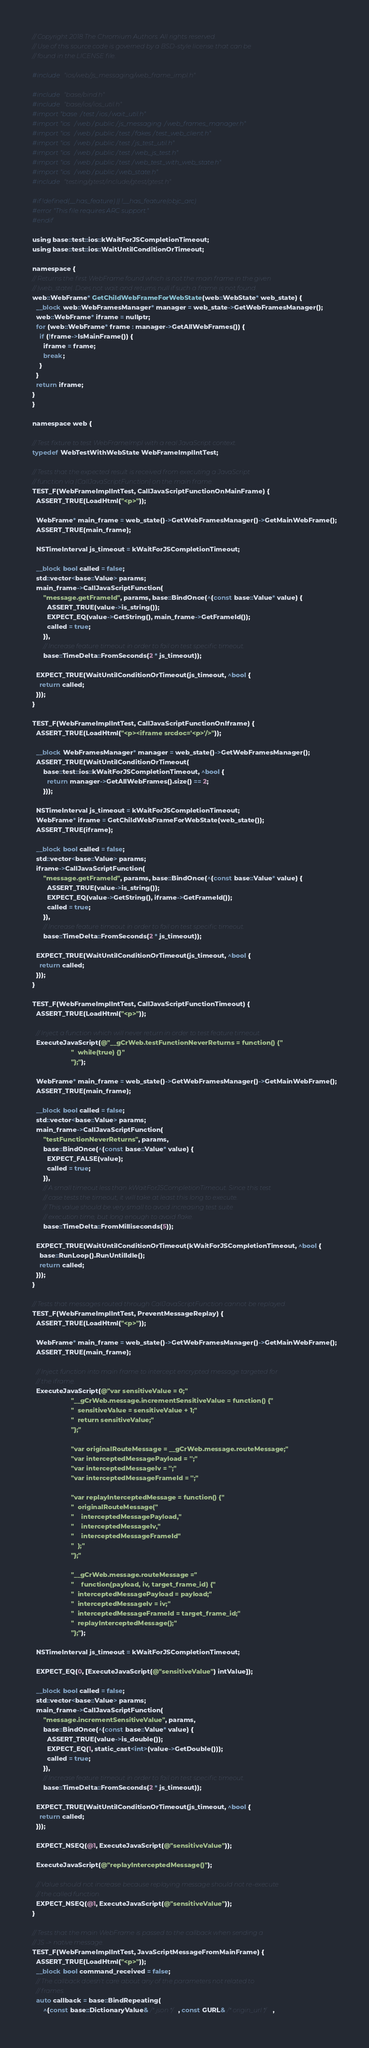<code> <loc_0><loc_0><loc_500><loc_500><_ObjectiveC_>// Copyright 2018 The Chromium Authors. All rights reserved.
// Use of this source code is governed by a BSD-style license that can be
// found in the LICENSE file.

#include "ios/web/js_messaging/web_frame_impl.h"

#include "base/bind.h"
#include "base/ios/ios_util.h"
#import "base/test/ios/wait_util.h"
#import "ios/web/public/js_messaging/web_frames_manager.h"
#import "ios/web/public/test/fakes/test_web_client.h"
#import "ios/web/public/test/js_test_util.h"
#import "ios/web/public/test/web_js_test.h"
#import "ios/web/public/test/web_test_with_web_state.h"
#import "ios/web/public/web_state.h"
#include "testing/gtest/include/gtest/gtest.h"

#if !defined(__has_feature) || !__has_feature(objc_arc)
#error "This file requires ARC support."
#endif

using base::test::ios::kWaitForJSCompletionTimeout;
using base::test::ios::WaitUntilConditionOrTimeout;

namespace {
// Returns the first WebFrame found which is not the main frame in the given
// |web_state|. Does not wait and returns null if such a frame is not found.
web::WebFrame* GetChildWebFrameForWebState(web::WebState* web_state) {
  __block web::WebFramesManager* manager = web_state->GetWebFramesManager();
  web::WebFrame* iframe = nullptr;
  for (web::WebFrame* frame : manager->GetAllWebFrames()) {
    if (!frame->IsMainFrame()) {
      iframe = frame;
      break;
    }
  }
  return iframe;
}
}

namespace web {

// Test fixture to test WebFrameImpl with a real JavaScript context.
typedef WebTestWithWebState WebFrameImplIntTest;

// Tests that the expected result is received from executing a JavaScript
// function via |CallJavaScriptFunction| on the main frame.
TEST_F(WebFrameImplIntTest, CallJavaScriptFunctionOnMainFrame) {
  ASSERT_TRUE(LoadHtml("<p>"));

  WebFrame* main_frame = web_state()->GetWebFramesManager()->GetMainWebFrame();
  ASSERT_TRUE(main_frame);

  NSTimeInterval js_timeout = kWaitForJSCompletionTimeout;

  __block bool called = false;
  std::vector<base::Value> params;
  main_frame->CallJavaScriptFunction(
      "message.getFrameId", params, base::BindOnce(^(const base::Value* value) {
        ASSERT_TRUE(value->is_string());
        EXPECT_EQ(value->GetString(), main_frame->GetFrameId());
        called = true;
      }),
      // Increase feature timeout in order to fail on test specific timeout.
      base::TimeDelta::FromSeconds(2 * js_timeout));

  EXPECT_TRUE(WaitUntilConditionOrTimeout(js_timeout, ^bool {
    return called;
  }));
}

TEST_F(WebFrameImplIntTest, CallJavaScriptFunctionOnIframe) {
  ASSERT_TRUE(LoadHtml("<p><iframe srcdoc='<p>'/>"));

  __block WebFramesManager* manager = web_state()->GetWebFramesManager();
  ASSERT_TRUE(WaitUntilConditionOrTimeout(
      base::test::ios::kWaitForJSCompletionTimeout, ^bool {
        return manager->GetAllWebFrames().size() == 2;
      }));

  NSTimeInterval js_timeout = kWaitForJSCompletionTimeout;
  WebFrame* iframe = GetChildWebFrameForWebState(web_state());
  ASSERT_TRUE(iframe);

  __block bool called = false;
  std::vector<base::Value> params;
  iframe->CallJavaScriptFunction(
      "message.getFrameId", params, base::BindOnce(^(const base::Value* value) {
        ASSERT_TRUE(value->is_string());
        EXPECT_EQ(value->GetString(), iframe->GetFrameId());
        called = true;
      }),
      // Increase feature timeout in order to fail on test specific timeout.
      base::TimeDelta::FromSeconds(2 * js_timeout));

  EXPECT_TRUE(WaitUntilConditionOrTimeout(js_timeout, ^bool {
    return called;
  }));
}

TEST_F(WebFrameImplIntTest, CallJavaScriptFunctionTimeout) {
  ASSERT_TRUE(LoadHtml("<p>"));

  // Inject a function which will never return in order to test feature timeout.
  ExecuteJavaScript(@"__gCrWeb.testFunctionNeverReturns = function() {"
                     "  while(true) {}"
                     "};");

  WebFrame* main_frame = web_state()->GetWebFramesManager()->GetMainWebFrame();
  ASSERT_TRUE(main_frame);

  __block bool called = false;
  std::vector<base::Value> params;
  main_frame->CallJavaScriptFunction(
      "testFunctionNeverReturns", params,
      base::BindOnce(^(const base::Value* value) {
        EXPECT_FALSE(value);
        called = true;
      }),
      // A small timeout less than kWaitForJSCompletionTimeout. Since this test
      // case tests the timeout, it will take at least this long to execute.
      // This value should be very small to avoid increasing test suite
      // execution time, but long enough to avoid flake.
      base::TimeDelta::FromMilliseconds(5));

  EXPECT_TRUE(WaitUntilConditionOrTimeout(kWaitForJSCompletionTimeout, ^bool {
    base::RunLoop().RunUntilIdle();
    return called;
  }));
}

// Tests that messages routed through CallJavaScriptFunction cannot be replayed.
TEST_F(WebFrameImplIntTest, PreventMessageReplay) {
  ASSERT_TRUE(LoadHtml("<p>"));

  WebFrame* main_frame = web_state()->GetWebFramesManager()->GetMainWebFrame();
  ASSERT_TRUE(main_frame);

  // Inject function into main frame to intercept encrypted message targeted for
  // the iframe.
  ExecuteJavaScript(@"var sensitiveValue = 0;"
                     "__gCrWeb.message.incrementSensitiveValue = function() {"
                     "  sensitiveValue = sensitiveValue + 1;"
                     "  return sensitiveValue;"
                     "};"

                     "var originalRouteMessage = __gCrWeb.message.routeMessage;"
                     "var interceptedMessagePayload = '';"
                     "var interceptedMessageIv = '';"
                     "var interceptedMessageFrameId = '';"

                     "var replayInterceptedMessage = function() {"
                     "  originalRouteMessage("
                     "    interceptedMessagePayload,"
                     "    interceptedMessageIv,"
                     "    interceptedMessageFrameId"
                     "  );"
                     "};"

                     "__gCrWeb.message.routeMessage ="
                     "    function(payload, iv, target_frame_id) {"
                     "  interceptedMessagePayload = payload;"
                     "  interceptedMessageIv = iv;"
                     "  interceptedMessageFrameId = target_frame_id;"
                     "  replayInterceptedMessage();"
                     "};");

  NSTimeInterval js_timeout = kWaitForJSCompletionTimeout;

  EXPECT_EQ(0, [ExecuteJavaScript(@"sensitiveValue") intValue]);

  __block bool called = false;
  std::vector<base::Value> params;
  main_frame->CallJavaScriptFunction(
      "message.incrementSensitiveValue", params,
      base::BindOnce(^(const base::Value* value) {
        ASSERT_TRUE(value->is_double());
        EXPECT_EQ(1, static_cast<int>(value->GetDouble()));
        called = true;
      }),
      // Increase feature timeout in order to fail on test specific timeout.
      base::TimeDelta::FromSeconds(2 * js_timeout));

  EXPECT_TRUE(WaitUntilConditionOrTimeout(js_timeout, ^bool {
    return called;
  }));

  EXPECT_NSEQ(@1, ExecuteJavaScript(@"sensitiveValue"));

  ExecuteJavaScript(@"replayInterceptedMessage()");

  // Value should not increase because replaying message should not re-execute
  // the called function.
  EXPECT_NSEQ(@1, ExecuteJavaScript(@"sensitiveValue"));
}

// Tests that the main WebFrame is passed to the callback when sending a
// JS -> native message.
TEST_F(WebFrameImplIntTest, JavaScriptMessageFromMainFrame) {
  ASSERT_TRUE(LoadHtml("<p>"));
  __block bool command_received = false;
  // The callback doesn't care about any of the parameters not related to
  // frames.
  auto callback = base::BindRepeating(
      ^(const base::DictionaryValue& /* json */, const GURL& /* origin_url */,</code> 